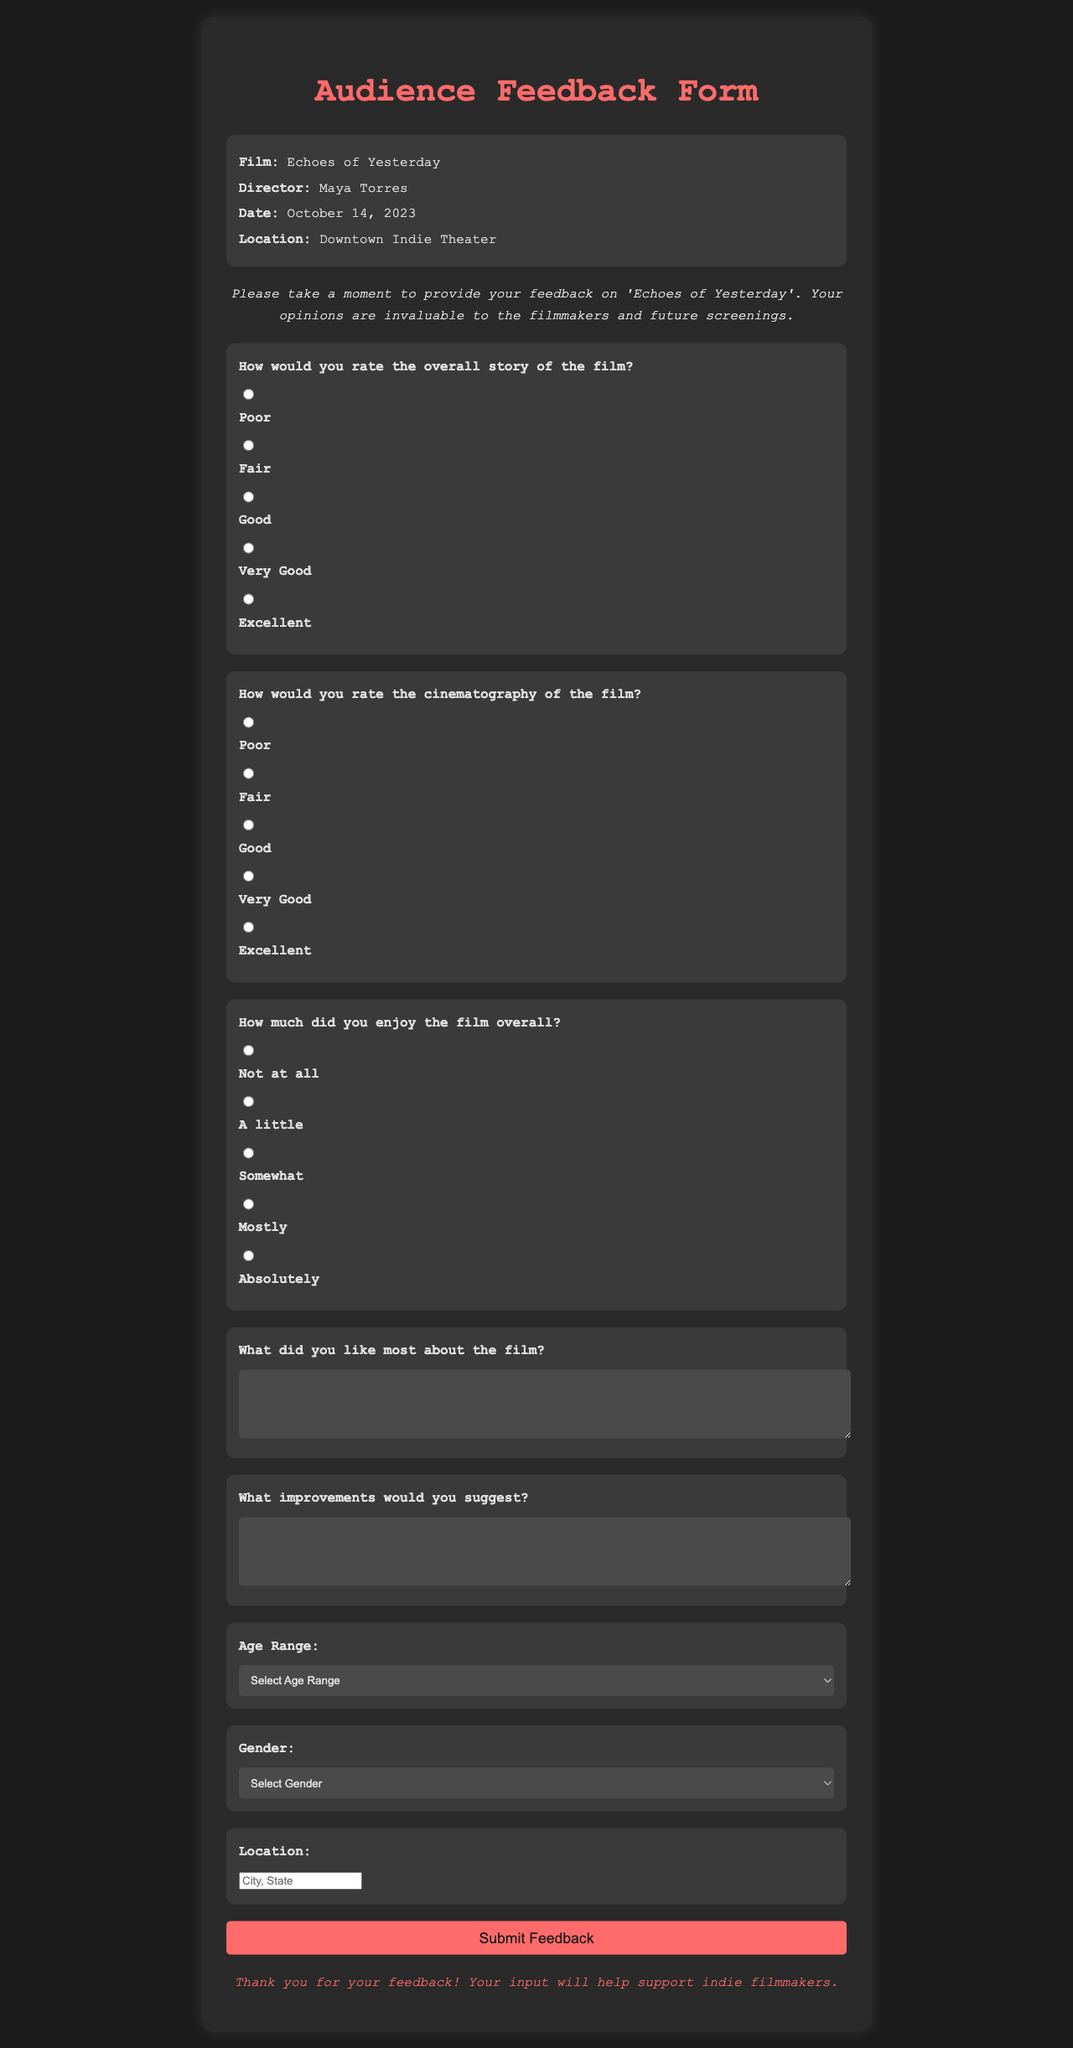What is the title of the film? The title of the film is provided in the heading of the document, which is "Echoes of Yesterday."
Answer: Echoes of Yesterday Who is the director of the film? The director's name is mentioned in the event info section of the document.
Answer: Maya Torres What is the date of the screening? The date of the screening is found in the event info section, indicating when the film was shown.
Answer: October 14, 2023 How would you rate the overall story of the film? The document provides a rating scale for the overall story, with options ranging from Poor to Excellent.
Answer: (1-5 depending on the user's choice) What improvements would you suggest? This is a question included in the feedback form designed to gather suggestions from audience members.
Answer: (Open-ended response) What age range options are provided in the form? The document lists different age ranges as response options in the feedback form.
Answer: Under 18, 18-24, 25-34, 35-44, 45-54, 55+ What color is used for the heading of the feedback form? The document specifies a color style for the heading, indicating its visual design.
Answer: #ff6b6b What is the purpose of the feedback form? The document includes a statement explaining the purpose of collecting feedback.
Answer: To support indie filmmakers 